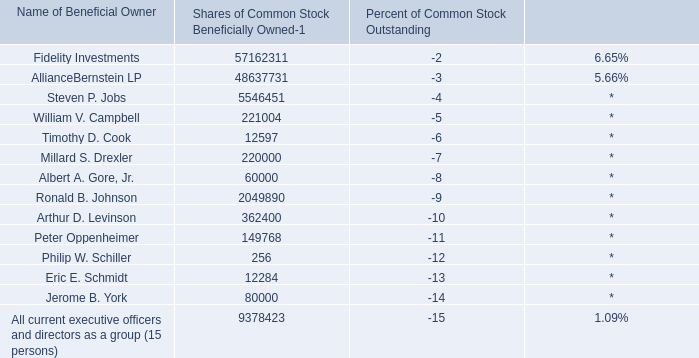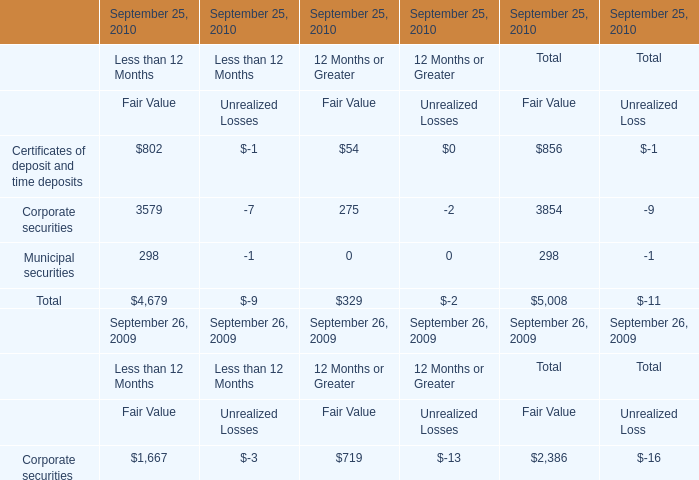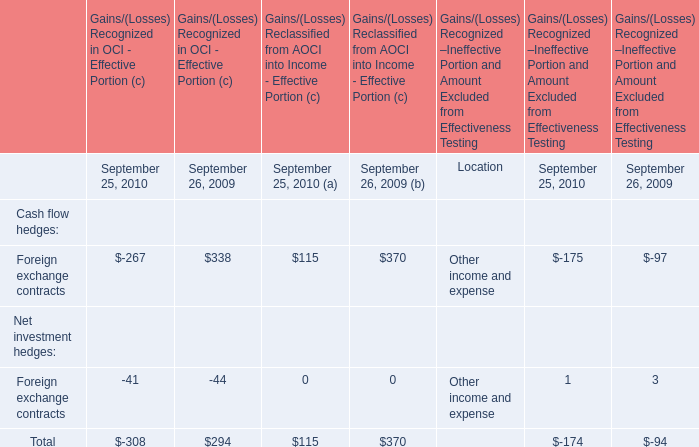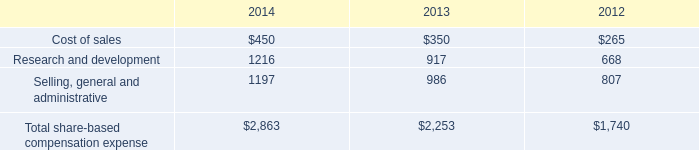What's the 10 % of total elements for Fair Value of Total in 2010? 
Computations: (5008 * 0.1)
Answer: 500.8. 